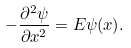Convert formula to latex. <formula><loc_0><loc_0><loc_500><loc_500>- \frac { \partial ^ { 2 } \psi } { \partial x ^ { 2 } } = E \psi ( x ) .</formula> 